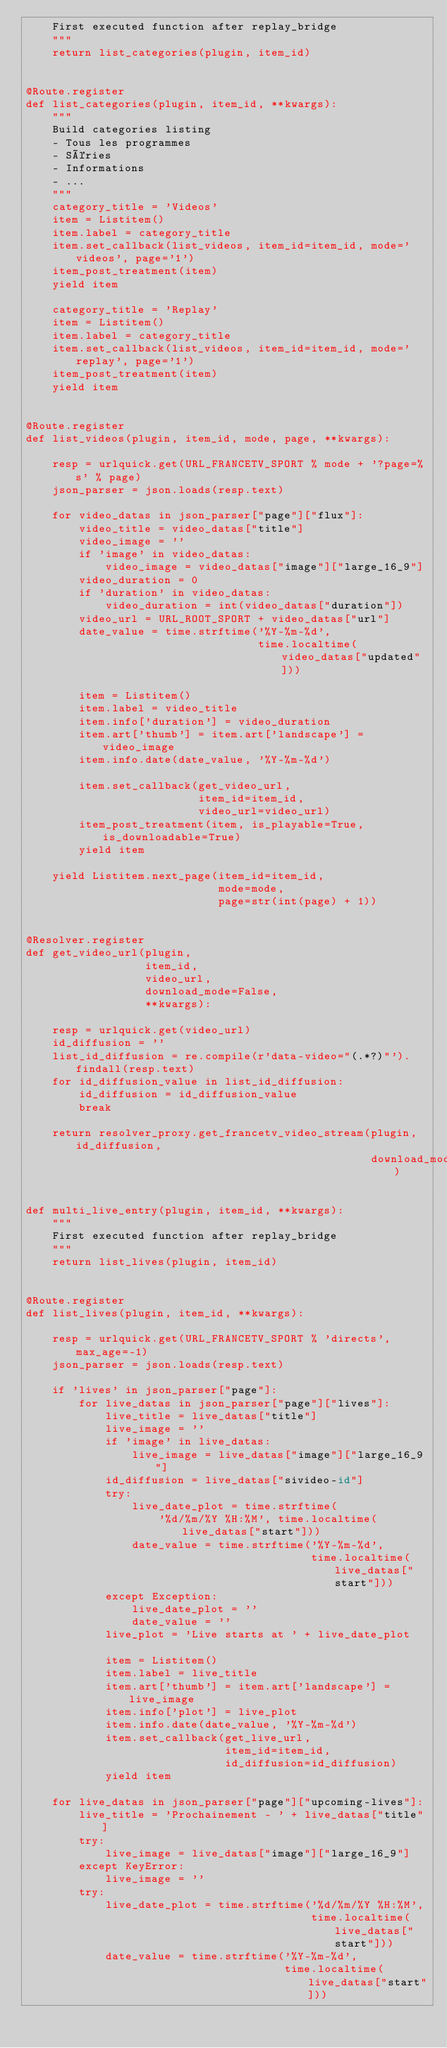Convert code to text. <code><loc_0><loc_0><loc_500><loc_500><_Python_>    First executed function after replay_bridge
    """
    return list_categories(plugin, item_id)


@Route.register
def list_categories(plugin, item_id, **kwargs):
    """
    Build categories listing
    - Tous les programmes
    - Séries
    - Informations
    - ...
    """
    category_title = 'Videos'
    item = Listitem()
    item.label = category_title
    item.set_callback(list_videos, item_id=item_id, mode='videos', page='1')
    item_post_treatment(item)
    yield item

    category_title = 'Replay'
    item = Listitem()
    item.label = category_title
    item.set_callback(list_videos, item_id=item_id, mode='replay', page='1')
    item_post_treatment(item)
    yield item


@Route.register
def list_videos(plugin, item_id, mode, page, **kwargs):

    resp = urlquick.get(URL_FRANCETV_SPORT % mode + '?page=%s' % page)
    json_parser = json.loads(resp.text)

    for video_datas in json_parser["page"]["flux"]:
        video_title = video_datas["title"]
        video_image = ''
        if 'image' in video_datas:
            video_image = video_datas["image"]["large_16_9"]
        video_duration = 0
        if 'duration' in video_datas:
            video_duration = int(video_datas["duration"])
        video_url = URL_ROOT_SPORT + video_datas["url"]
        date_value = time.strftime('%Y-%m-%d',
                                   time.localtime(video_datas["updated"]))

        item = Listitem()
        item.label = video_title
        item.info['duration'] = video_duration
        item.art['thumb'] = item.art['landscape'] = video_image
        item.info.date(date_value, '%Y-%m-%d')

        item.set_callback(get_video_url,
                          item_id=item_id,
                          video_url=video_url)
        item_post_treatment(item, is_playable=True, is_downloadable=True)
        yield item

    yield Listitem.next_page(item_id=item_id,
                             mode=mode,
                             page=str(int(page) + 1))


@Resolver.register
def get_video_url(plugin,
                  item_id,
                  video_url,
                  download_mode=False,
                  **kwargs):

    resp = urlquick.get(video_url)
    id_diffusion = ''
    list_id_diffusion = re.compile(r'data-video="(.*?)"').findall(resp.text)
    for id_diffusion_value in list_id_diffusion:
        id_diffusion = id_diffusion_value
        break

    return resolver_proxy.get_francetv_video_stream(plugin, id_diffusion,
                                                    download_mode)


def multi_live_entry(plugin, item_id, **kwargs):
    """
    First executed function after replay_bridge
    """
    return list_lives(plugin, item_id)


@Route.register
def list_lives(plugin, item_id, **kwargs):

    resp = urlquick.get(URL_FRANCETV_SPORT % 'directs', max_age=-1)
    json_parser = json.loads(resp.text)

    if 'lives' in json_parser["page"]:
        for live_datas in json_parser["page"]["lives"]:
            live_title = live_datas["title"]
            live_image = ''
            if 'image' in live_datas:
                live_image = live_datas["image"]["large_16_9"]
            id_diffusion = live_datas["sivideo-id"]
            try:
                live_date_plot = time.strftime(
                    '%d/%m/%Y %H:%M', time.localtime(live_datas["start"]))
                date_value = time.strftime('%Y-%m-%d',
                                           time.localtime(live_datas["start"]))
            except Exception:
                live_date_plot = ''
                date_value = ''
            live_plot = 'Live starts at ' + live_date_plot

            item = Listitem()
            item.label = live_title
            item.art['thumb'] = item.art['landscape'] = live_image
            item.info['plot'] = live_plot
            item.info.date(date_value, '%Y-%m-%d')
            item.set_callback(get_live_url,
                              item_id=item_id,
                              id_diffusion=id_diffusion)
            yield item

    for live_datas in json_parser["page"]["upcoming-lives"]:
        live_title = 'Prochainement - ' + live_datas["title"]
        try:
            live_image = live_datas["image"]["large_16_9"]
        except KeyError:
            live_image = ''
        try:
            live_date_plot = time.strftime('%d/%m/%Y %H:%M',
                                           time.localtime(live_datas["start"]))
            date_value = time.strftime('%Y-%m-%d',
                                       time.localtime(live_datas["start"]))</code> 